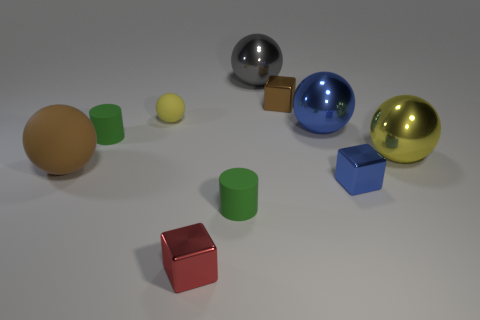Subtract all gray balls. How many balls are left? 4 Subtract all red cylinders. Subtract all brown blocks. How many cylinders are left? 2 Subtract all cylinders. How many objects are left? 8 Add 4 small blue metallic objects. How many small blue metallic objects are left? 5 Add 1 gray matte cylinders. How many gray matte cylinders exist? 1 Subtract 0 cyan cylinders. How many objects are left? 10 Subtract all small red things. Subtract all blue cubes. How many objects are left? 8 